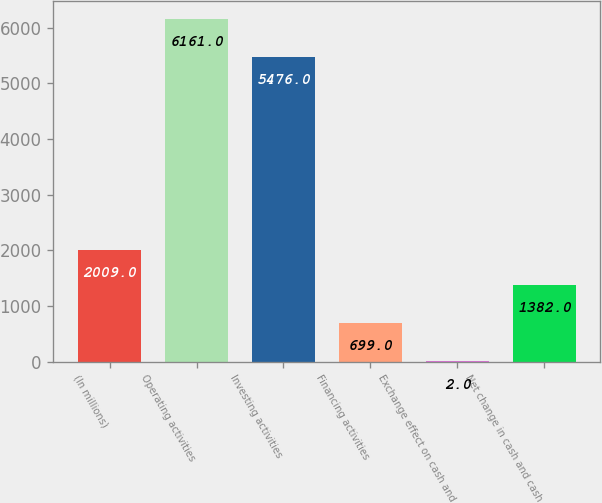<chart> <loc_0><loc_0><loc_500><loc_500><bar_chart><fcel>(In millions)<fcel>Operating activities<fcel>Investing activities<fcel>Financing activities<fcel>Exchange effect on cash and<fcel>Net change in cash and cash<nl><fcel>2009<fcel>6161<fcel>5476<fcel>699<fcel>2<fcel>1382<nl></chart> 